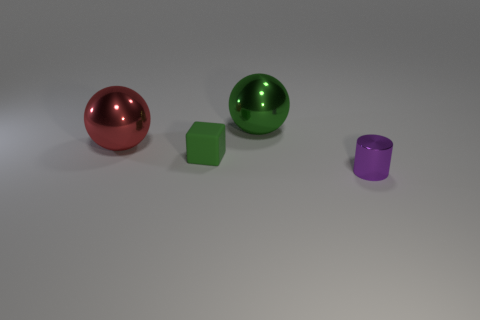Are there any small brown shiny things that have the same shape as the tiny green matte thing?
Your answer should be very brief. No. What is the color of the tiny object right of the large thing to the right of the small thing to the left of the tiny metal cylinder?
Ensure brevity in your answer.  Purple. How many metallic things are big purple things or small things?
Give a very brief answer. 1. Are there more small green blocks that are left of the tiny green matte object than big red spheres that are on the right side of the green shiny object?
Your response must be concise. No. How many other objects are the same size as the purple thing?
Your answer should be very brief. 1. How big is the green matte cube that is on the right side of the large metal sphere that is left of the tiny green object?
Ensure brevity in your answer.  Small. How many small things are red spheres or purple cylinders?
Keep it short and to the point. 1. What size is the thing that is to the right of the large object behind the large sphere in front of the green metal thing?
Ensure brevity in your answer.  Small. Is there any other thing that has the same color as the tiny cylinder?
Provide a succinct answer. No. The big thing that is in front of the shiny object behind the large thing left of the green rubber cube is made of what material?
Your answer should be compact. Metal. 